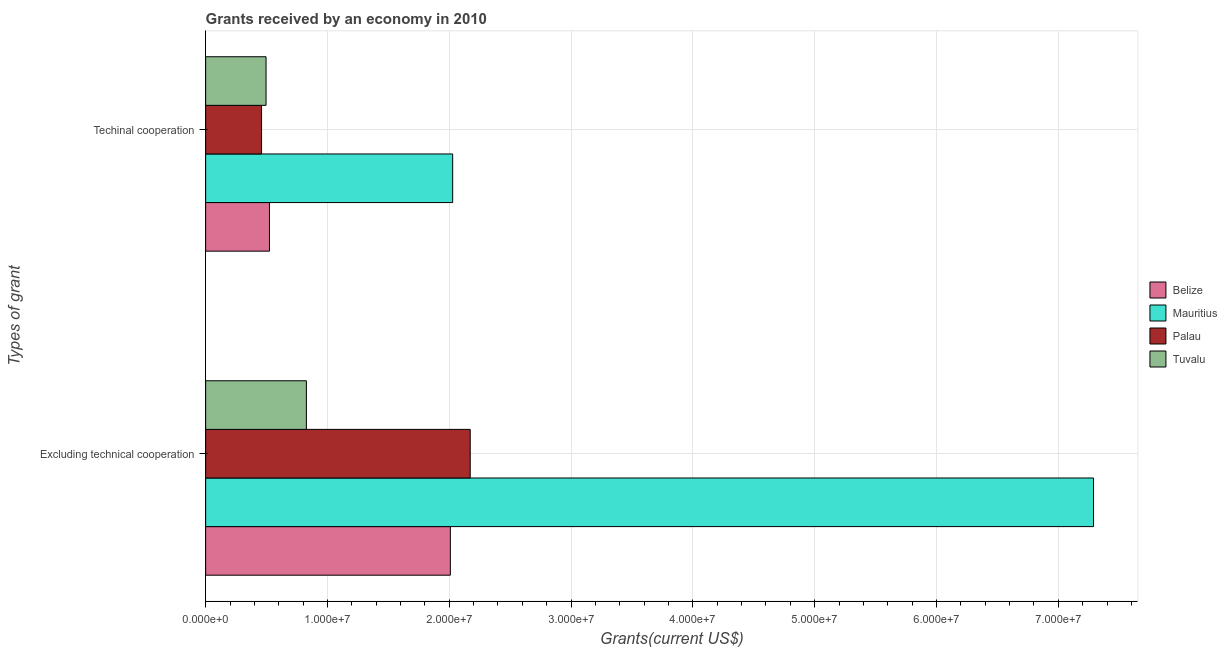How many different coloured bars are there?
Your answer should be compact. 4. Are the number of bars on each tick of the Y-axis equal?
Offer a terse response. Yes. How many bars are there on the 2nd tick from the top?
Give a very brief answer. 4. What is the label of the 1st group of bars from the top?
Your answer should be very brief. Techinal cooperation. What is the amount of grants received(including technical cooperation) in Tuvalu?
Keep it short and to the point. 4.96e+06. Across all countries, what is the maximum amount of grants received(including technical cooperation)?
Your answer should be very brief. 2.03e+07. Across all countries, what is the minimum amount of grants received(excluding technical cooperation)?
Provide a short and direct response. 8.27e+06. In which country was the amount of grants received(excluding technical cooperation) maximum?
Provide a succinct answer. Mauritius. In which country was the amount of grants received(excluding technical cooperation) minimum?
Provide a short and direct response. Tuvalu. What is the total amount of grants received(including technical cooperation) in the graph?
Your answer should be very brief. 3.51e+07. What is the difference between the amount of grants received(including technical cooperation) in Palau and that in Mauritius?
Offer a very short reply. -1.57e+07. What is the difference between the amount of grants received(including technical cooperation) in Palau and the amount of grants received(excluding technical cooperation) in Mauritius?
Keep it short and to the point. -6.83e+07. What is the average amount of grants received(including technical cooperation) per country?
Keep it short and to the point. 8.77e+06. What is the difference between the amount of grants received(including technical cooperation) and amount of grants received(excluding technical cooperation) in Tuvalu?
Provide a short and direct response. -3.31e+06. In how many countries, is the amount of grants received(excluding technical cooperation) greater than 70000000 US$?
Offer a very short reply. 1. What is the ratio of the amount of grants received(excluding technical cooperation) in Belize to that in Palau?
Offer a terse response. 0.92. Is the amount of grants received(including technical cooperation) in Palau less than that in Tuvalu?
Keep it short and to the point. Yes. In how many countries, is the amount of grants received(including technical cooperation) greater than the average amount of grants received(including technical cooperation) taken over all countries?
Offer a very short reply. 1. What does the 4th bar from the top in Excluding technical cooperation represents?
Your response must be concise. Belize. What does the 3rd bar from the bottom in Excluding technical cooperation represents?
Ensure brevity in your answer.  Palau. How many bars are there?
Your response must be concise. 8. How many countries are there in the graph?
Your response must be concise. 4. Does the graph contain any zero values?
Give a very brief answer. No. Does the graph contain grids?
Give a very brief answer. Yes. Where does the legend appear in the graph?
Your answer should be compact. Center right. What is the title of the graph?
Your response must be concise. Grants received by an economy in 2010. What is the label or title of the X-axis?
Give a very brief answer. Grants(current US$). What is the label or title of the Y-axis?
Your answer should be very brief. Types of grant. What is the Grants(current US$) in Belize in Excluding technical cooperation?
Your response must be concise. 2.01e+07. What is the Grants(current US$) of Mauritius in Excluding technical cooperation?
Make the answer very short. 7.29e+07. What is the Grants(current US$) of Palau in Excluding technical cooperation?
Offer a very short reply. 2.17e+07. What is the Grants(current US$) in Tuvalu in Excluding technical cooperation?
Give a very brief answer. 8.27e+06. What is the Grants(current US$) in Belize in Techinal cooperation?
Your response must be concise. 5.24e+06. What is the Grants(current US$) of Mauritius in Techinal cooperation?
Your answer should be compact. 2.03e+07. What is the Grants(current US$) in Palau in Techinal cooperation?
Give a very brief answer. 4.59e+06. What is the Grants(current US$) of Tuvalu in Techinal cooperation?
Your answer should be compact. 4.96e+06. Across all Types of grant, what is the maximum Grants(current US$) of Belize?
Provide a short and direct response. 2.01e+07. Across all Types of grant, what is the maximum Grants(current US$) in Mauritius?
Give a very brief answer. 7.29e+07. Across all Types of grant, what is the maximum Grants(current US$) in Palau?
Your answer should be compact. 2.17e+07. Across all Types of grant, what is the maximum Grants(current US$) of Tuvalu?
Your answer should be compact. 8.27e+06. Across all Types of grant, what is the minimum Grants(current US$) of Belize?
Your answer should be very brief. 5.24e+06. Across all Types of grant, what is the minimum Grants(current US$) in Mauritius?
Keep it short and to the point. 2.03e+07. Across all Types of grant, what is the minimum Grants(current US$) of Palau?
Make the answer very short. 4.59e+06. Across all Types of grant, what is the minimum Grants(current US$) in Tuvalu?
Give a very brief answer. 4.96e+06. What is the total Grants(current US$) of Belize in the graph?
Ensure brevity in your answer.  2.53e+07. What is the total Grants(current US$) in Mauritius in the graph?
Give a very brief answer. 9.32e+07. What is the total Grants(current US$) in Palau in the graph?
Give a very brief answer. 2.63e+07. What is the total Grants(current US$) in Tuvalu in the graph?
Provide a short and direct response. 1.32e+07. What is the difference between the Grants(current US$) in Belize in Excluding technical cooperation and that in Techinal cooperation?
Provide a short and direct response. 1.48e+07. What is the difference between the Grants(current US$) of Mauritius in Excluding technical cooperation and that in Techinal cooperation?
Offer a terse response. 5.26e+07. What is the difference between the Grants(current US$) of Palau in Excluding technical cooperation and that in Techinal cooperation?
Your response must be concise. 1.71e+07. What is the difference between the Grants(current US$) of Tuvalu in Excluding technical cooperation and that in Techinal cooperation?
Your answer should be very brief. 3.31e+06. What is the difference between the Grants(current US$) in Belize in Excluding technical cooperation and the Grants(current US$) in Mauritius in Techinal cooperation?
Offer a very short reply. -1.90e+05. What is the difference between the Grants(current US$) in Belize in Excluding technical cooperation and the Grants(current US$) in Palau in Techinal cooperation?
Your answer should be very brief. 1.55e+07. What is the difference between the Grants(current US$) of Belize in Excluding technical cooperation and the Grants(current US$) of Tuvalu in Techinal cooperation?
Your answer should be very brief. 1.51e+07. What is the difference between the Grants(current US$) of Mauritius in Excluding technical cooperation and the Grants(current US$) of Palau in Techinal cooperation?
Provide a short and direct response. 6.83e+07. What is the difference between the Grants(current US$) in Mauritius in Excluding technical cooperation and the Grants(current US$) in Tuvalu in Techinal cooperation?
Keep it short and to the point. 6.79e+07. What is the difference between the Grants(current US$) in Palau in Excluding technical cooperation and the Grants(current US$) in Tuvalu in Techinal cooperation?
Make the answer very short. 1.68e+07. What is the average Grants(current US$) of Belize per Types of grant?
Your answer should be compact. 1.27e+07. What is the average Grants(current US$) in Mauritius per Types of grant?
Keep it short and to the point. 4.66e+07. What is the average Grants(current US$) of Palau per Types of grant?
Give a very brief answer. 1.32e+07. What is the average Grants(current US$) of Tuvalu per Types of grant?
Provide a succinct answer. 6.62e+06. What is the difference between the Grants(current US$) in Belize and Grants(current US$) in Mauritius in Excluding technical cooperation?
Keep it short and to the point. -5.28e+07. What is the difference between the Grants(current US$) in Belize and Grants(current US$) in Palau in Excluding technical cooperation?
Keep it short and to the point. -1.63e+06. What is the difference between the Grants(current US$) of Belize and Grants(current US$) of Tuvalu in Excluding technical cooperation?
Your response must be concise. 1.18e+07. What is the difference between the Grants(current US$) in Mauritius and Grants(current US$) in Palau in Excluding technical cooperation?
Offer a very short reply. 5.12e+07. What is the difference between the Grants(current US$) of Mauritius and Grants(current US$) of Tuvalu in Excluding technical cooperation?
Provide a succinct answer. 6.46e+07. What is the difference between the Grants(current US$) of Palau and Grants(current US$) of Tuvalu in Excluding technical cooperation?
Give a very brief answer. 1.34e+07. What is the difference between the Grants(current US$) of Belize and Grants(current US$) of Mauritius in Techinal cooperation?
Offer a very short reply. -1.50e+07. What is the difference between the Grants(current US$) in Belize and Grants(current US$) in Palau in Techinal cooperation?
Ensure brevity in your answer.  6.50e+05. What is the difference between the Grants(current US$) in Mauritius and Grants(current US$) in Palau in Techinal cooperation?
Offer a terse response. 1.57e+07. What is the difference between the Grants(current US$) in Mauritius and Grants(current US$) in Tuvalu in Techinal cooperation?
Make the answer very short. 1.53e+07. What is the difference between the Grants(current US$) of Palau and Grants(current US$) of Tuvalu in Techinal cooperation?
Provide a succinct answer. -3.70e+05. What is the ratio of the Grants(current US$) in Belize in Excluding technical cooperation to that in Techinal cooperation?
Give a very brief answer. 3.83. What is the ratio of the Grants(current US$) in Mauritius in Excluding technical cooperation to that in Techinal cooperation?
Ensure brevity in your answer.  3.59. What is the ratio of the Grants(current US$) of Palau in Excluding technical cooperation to that in Techinal cooperation?
Ensure brevity in your answer.  4.73. What is the ratio of the Grants(current US$) of Tuvalu in Excluding technical cooperation to that in Techinal cooperation?
Offer a very short reply. 1.67. What is the difference between the highest and the second highest Grants(current US$) in Belize?
Keep it short and to the point. 1.48e+07. What is the difference between the highest and the second highest Grants(current US$) in Mauritius?
Provide a short and direct response. 5.26e+07. What is the difference between the highest and the second highest Grants(current US$) of Palau?
Offer a terse response. 1.71e+07. What is the difference between the highest and the second highest Grants(current US$) of Tuvalu?
Your answer should be compact. 3.31e+06. What is the difference between the highest and the lowest Grants(current US$) of Belize?
Your answer should be very brief. 1.48e+07. What is the difference between the highest and the lowest Grants(current US$) in Mauritius?
Your answer should be very brief. 5.26e+07. What is the difference between the highest and the lowest Grants(current US$) in Palau?
Provide a succinct answer. 1.71e+07. What is the difference between the highest and the lowest Grants(current US$) in Tuvalu?
Keep it short and to the point. 3.31e+06. 